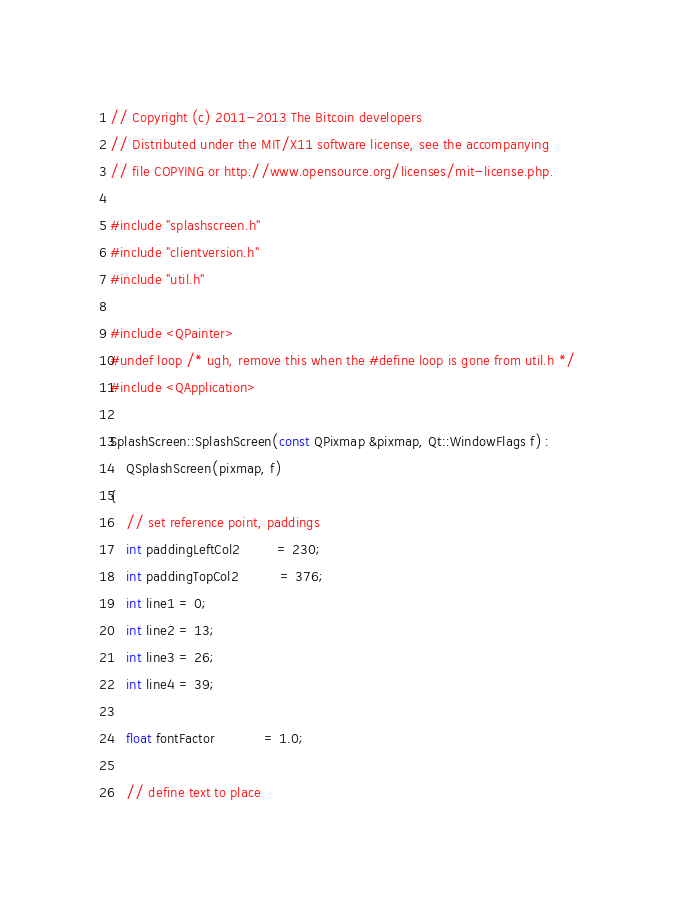<code> <loc_0><loc_0><loc_500><loc_500><_C++_>// Copyright (c) 2011-2013 The Bitcoin developers
// Distributed under the MIT/X11 software license, see the accompanying
// file COPYING or http://www.opensource.org/licenses/mit-license.php.

#include "splashscreen.h"
#include "clientversion.h"
#include "util.h"

#include <QPainter>
#undef loop /* ugh, remove this when the #define loop is gone from util.h */
#include <QApplication>

SplashScreen::SplashScreen(const QPixmap &pixmap, Qt::WindowFlags f) :
    QSplashScreen(pixmap, f)
{
    // set reference point, paddings
    int paddingLeftCol2         = 230;
    int paddingTopCol2          = 376;
    int line1 = 0;
    int line2 = 13;
    int line3 = 26;
    int line4 = 39;

    float fontFactor            = 1.0;

    // define text to place</code> 